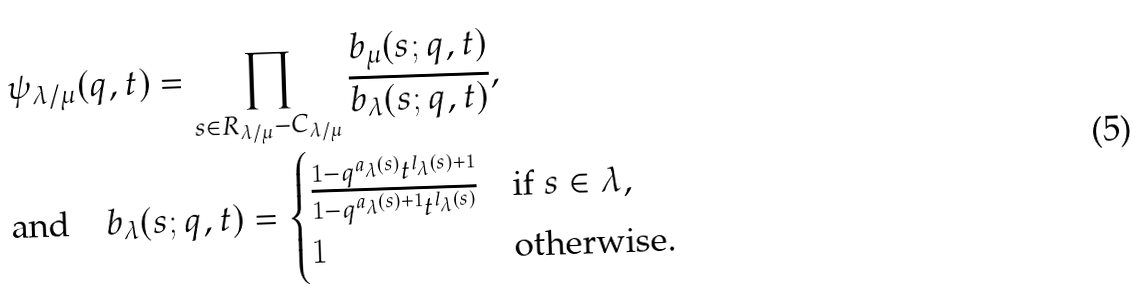<formula> <loc_0><loc_0><loc_500><loc_500>& \psi _ { \lambda / \mu } ( q , t ) = \prod _ { s \in R _ { \lambda / \mu } - C _ { \lambda / \mu } } \frac { b _ { \mu } ( s ; q , t ) } { b _ { \lambda } ( s ; q , t ) } , \\ & \text {and} \quad b _ { \lambda } ( s ; q , t ) = \begin{cases} \frac { 1 - q ^ { a _ { \lambda } ( s ) } t ^ { l _ { \lambda } ( s ) + 1 } } { 1 - q ^ { a _ { \lambda } ( s ) + 1 } t ^ { l _ { \lambda } ( s ) } } & \text {if $ s\in \lambda,$ } \\ 1 & \text {otherwise.} \end{cases}</formula> 